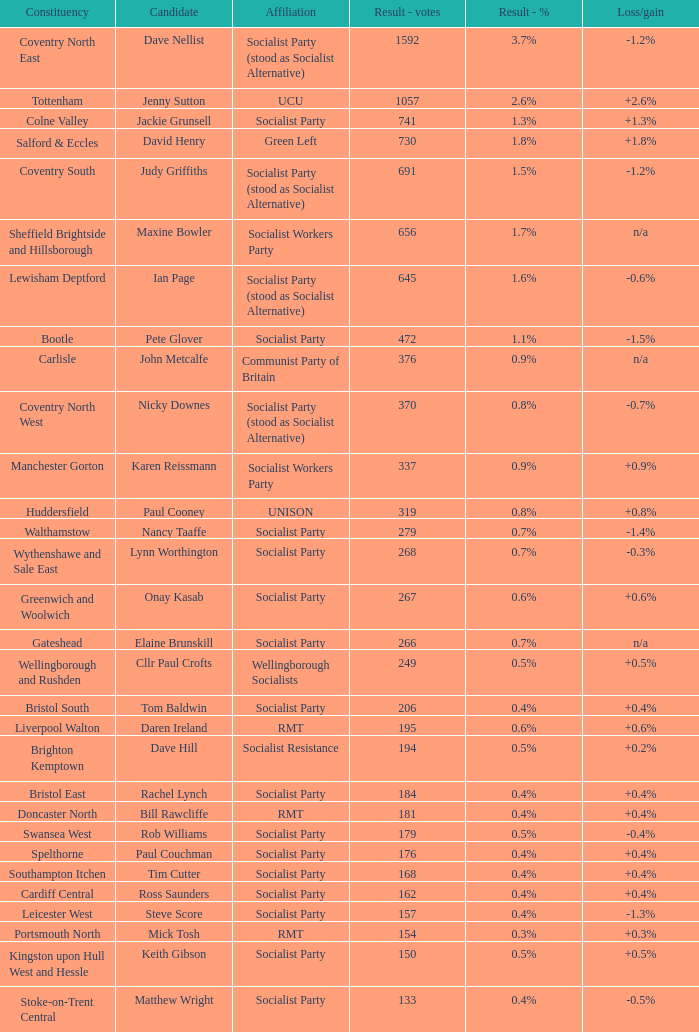What is every affiliation for candidate Daren Ireland? RMT. 